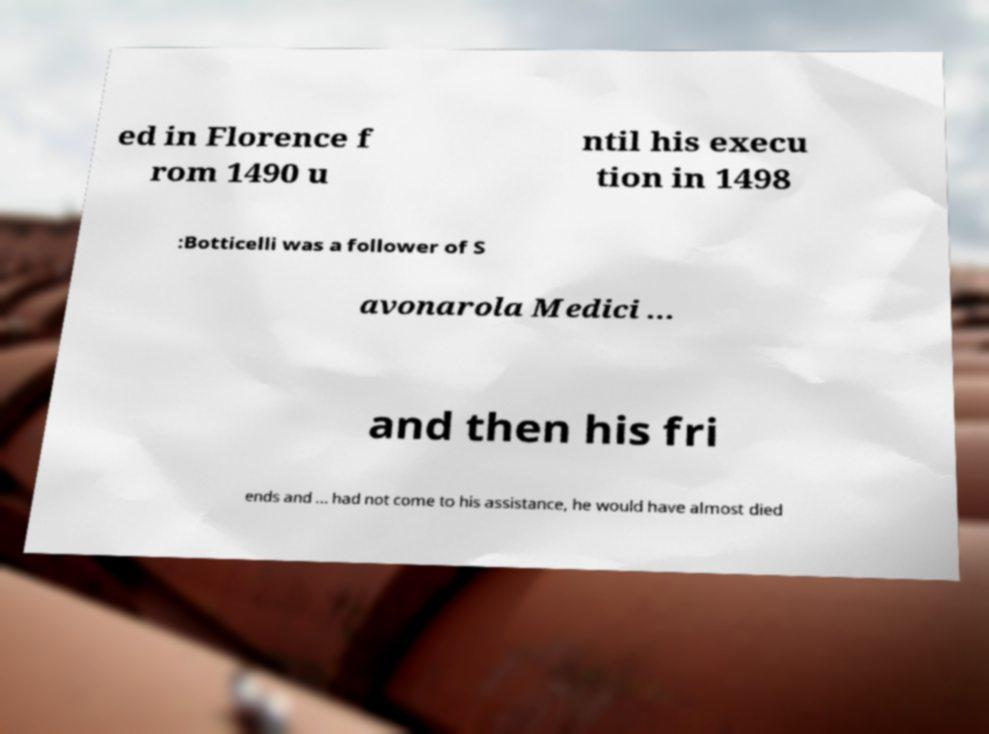Please identify and transcribe the text found in this image. ed in Florence f rom 1490 u ntil his execu tion in 1498 :Botticelli was a follower of S avonarola Medici ... and then his fri ends and ... had not come to his assistance, he would have almost died 